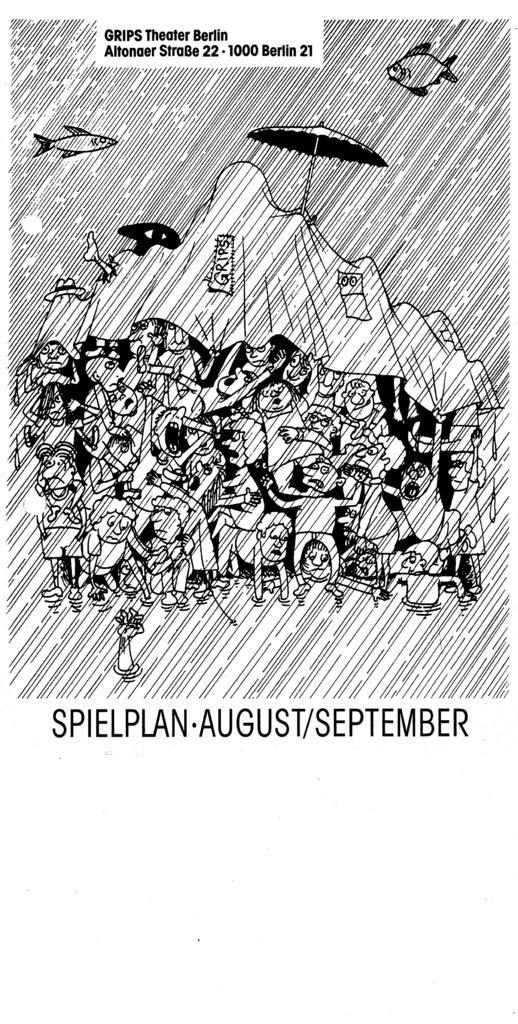How would you summarize this image in a sentence or two? In the foreground of this poster, there is some text and the sketch of people, a cloth, an umbrella, fishes and the rain. 